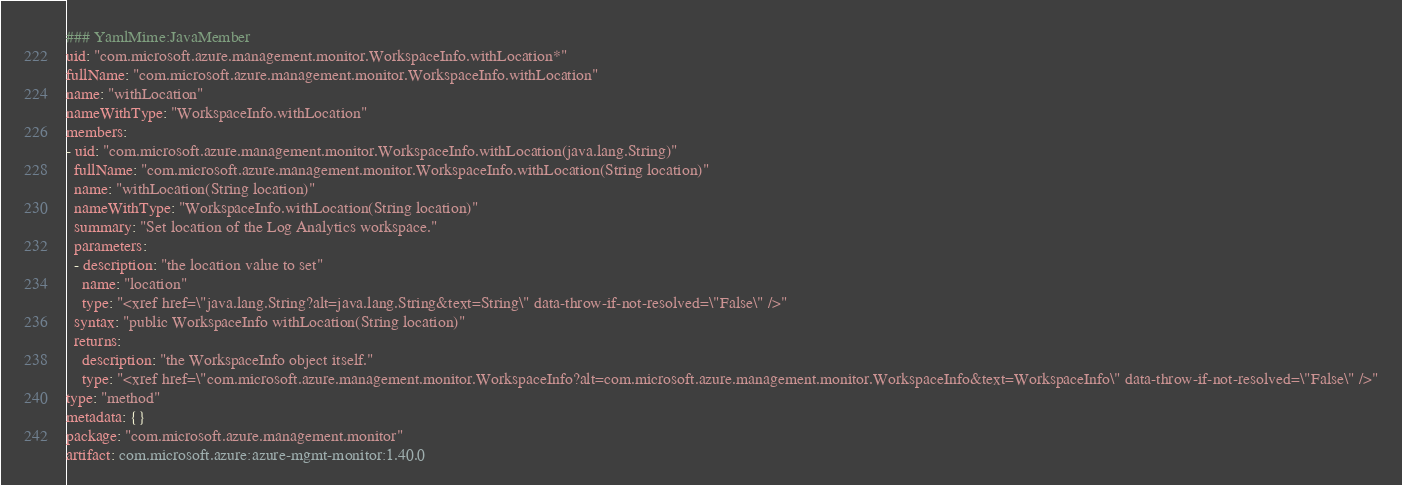Convert code to text. <code><loc_0><loc_0><loc_500><loc_500><_YAML_>### YamlMime:JavaMember
uid: "com.microsoft.azure.management.monitor.WorkspaceInfo.withLocation*"
fullName: "com.microsoft.azure.management.monitor.WorkspaceInfo.withLocation"
name: "withLocation"
nameWithType: "WorkspaceInfo.withLocation"
members:
- uid: "com.microsoft.azure.management.monitor.WorkspaceInfo.withLocation(java.lang.String)"
  fullName: "com.microsoft.azure.management.monitor.WorkspaceInfo.withLocation(String location)"
  name: "withLocation(String location)"
  nameWithType: "WorkspaceInfo.withLocation(String location)"
  summary: "Set location of the Log Analytics workspace."
  parameters:
  - description: "the location value to set"
    name: "location"
    type: "<xref href=\"java.lang.String?alt=java.lang.String&text=String\" data-throw-if-not-resolved=\"False\" />"
  syntax: "public WorkspaceInfo withLocation(String location)"
  returns:
    description: "the WorkspaceInfo object itself."
    type: "<xref href=\"com.microsoft.azure.management.monitor.WorkspaceInfo?alt=com.microsoft.azure.management.monitor.WorkspaceInfo&text=WorkspaceInfo\" data-throw-if-not-resolved=\"False\" />"
type: "method"
metadata: {}
package: "com.microsoft.azure.management.monitor"
artifact: com.microsoft.azure:azure-mgmt-monitor:1.40.0
</code> 